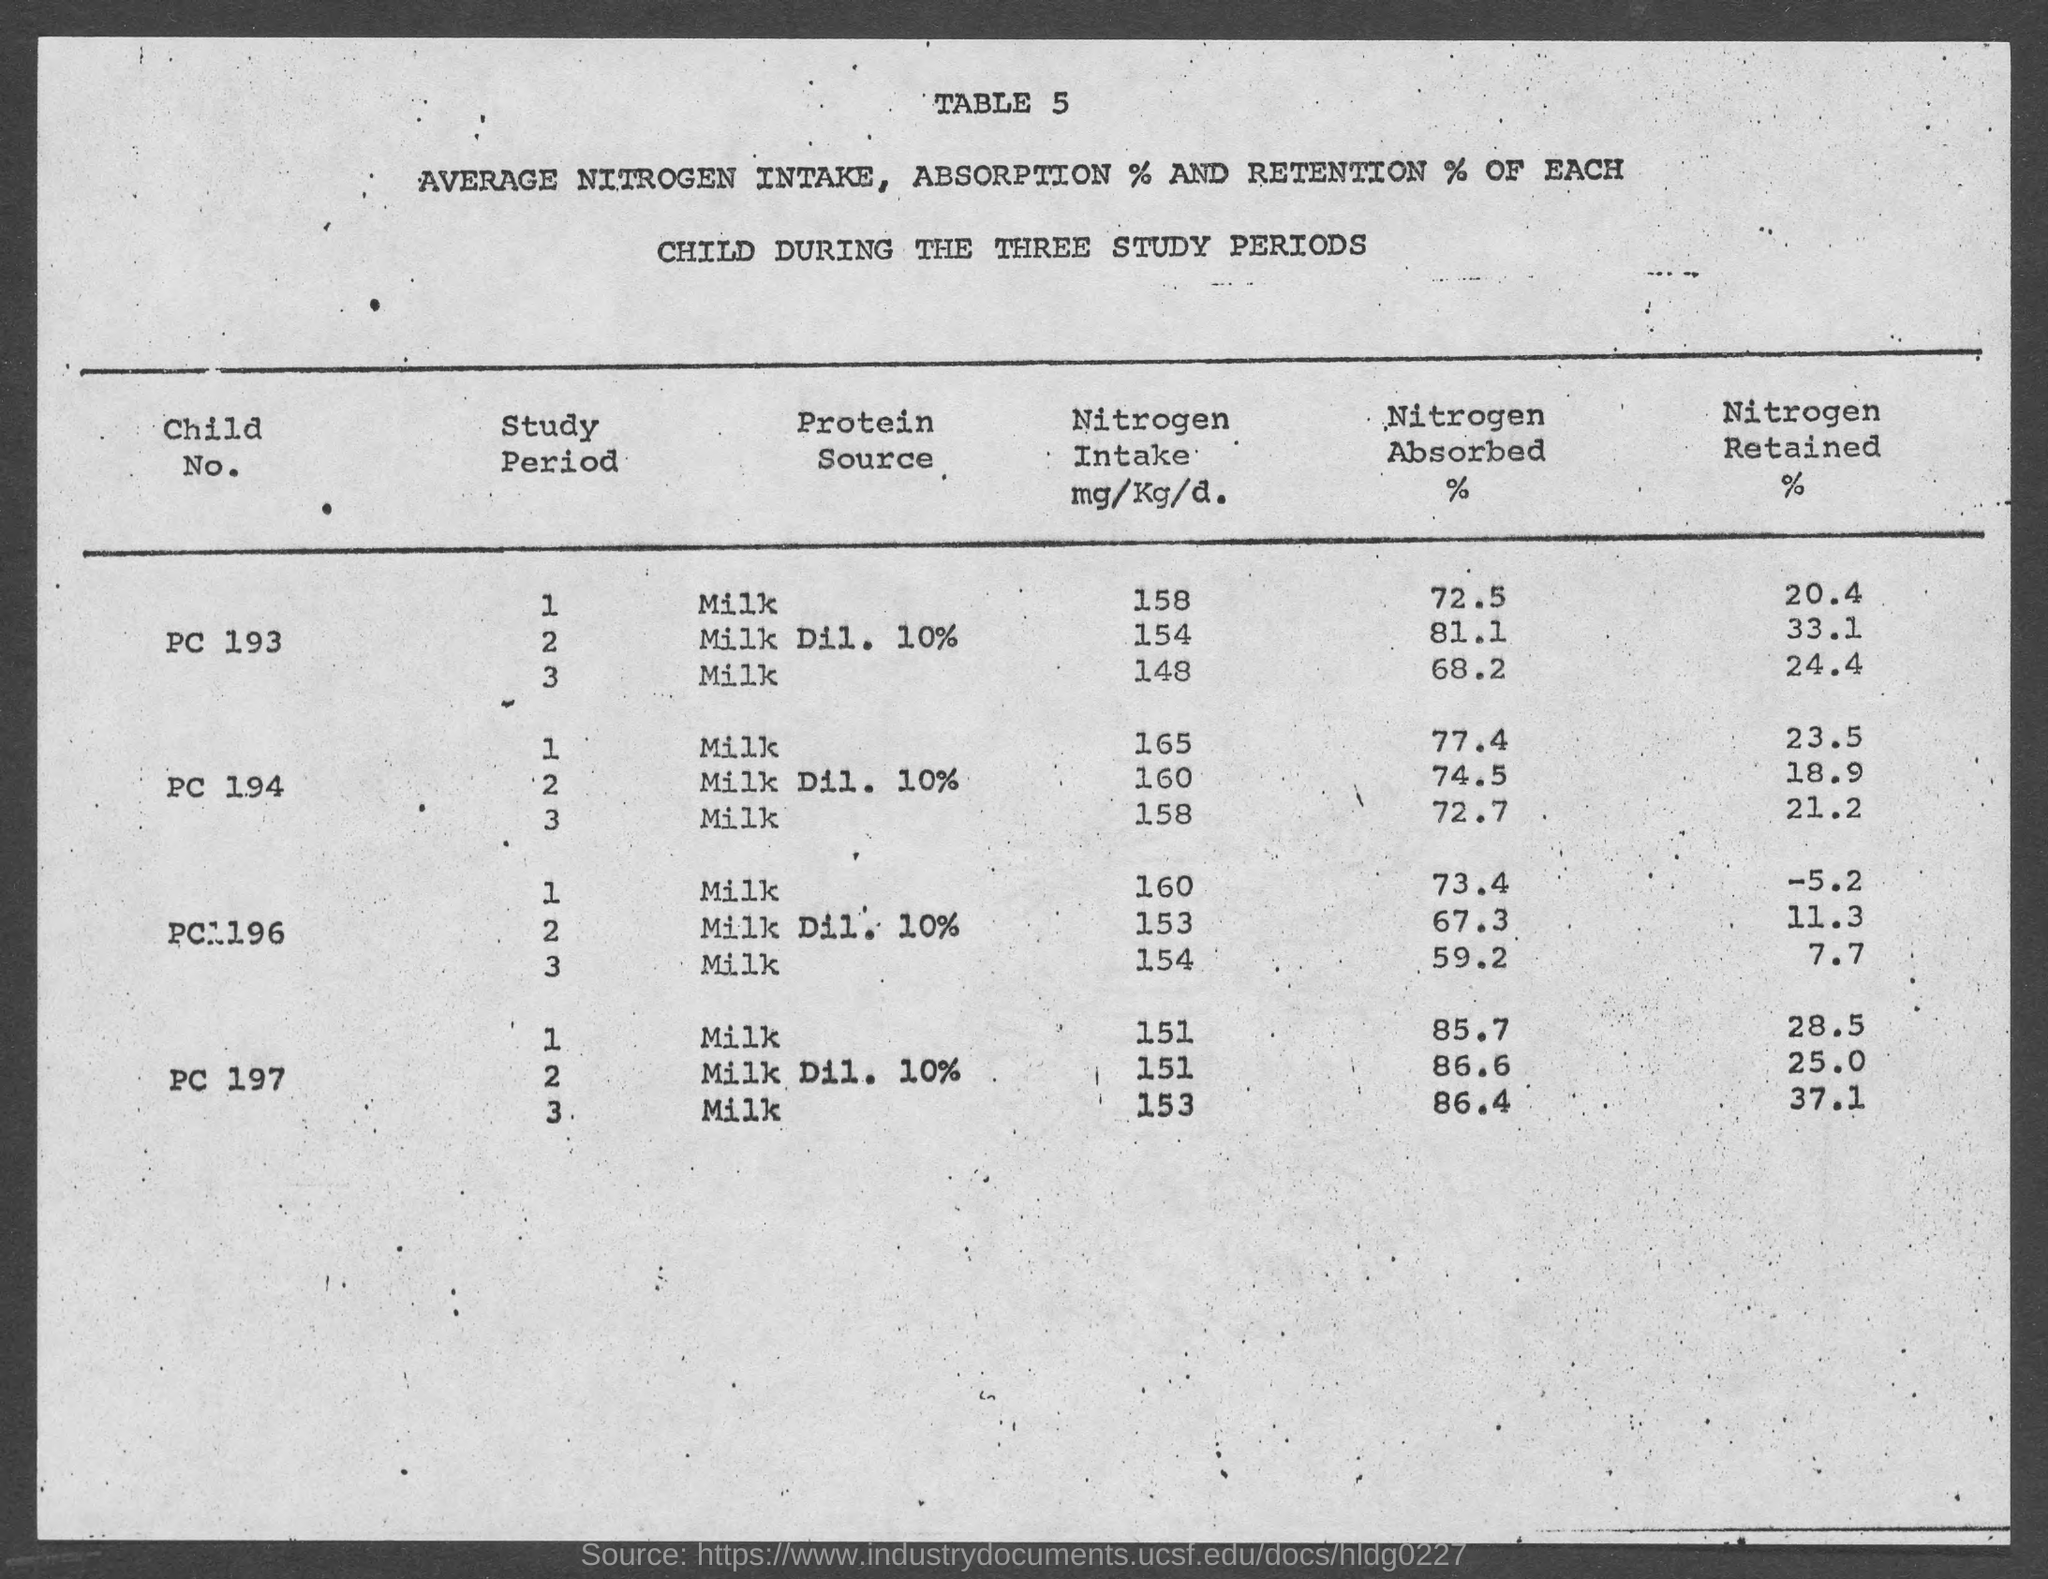Point out several critical features in this image. During the study period 3, child number PC 196 absorbed 59.2% of the nitrogen that was administered to them. During the study period 1, approximately 72.5% of the nitrogen was absorbed by child number PC 193. During the study period 3, child number 197 ingested an amount of nitrogen that was 153... During the study period 3, child number PC 193 retained 24.4% of the nitrogen that was administered to them. 